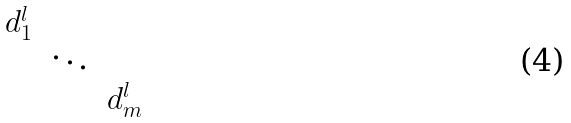<formula> <loc_0><loc_0><loc_500><loc_500>\begin{matrix} d _ { 1 } ^ { l } & & \\ & \ddots & \\ & & d _ { m } ^ { l } \end{matrix}</formula> 